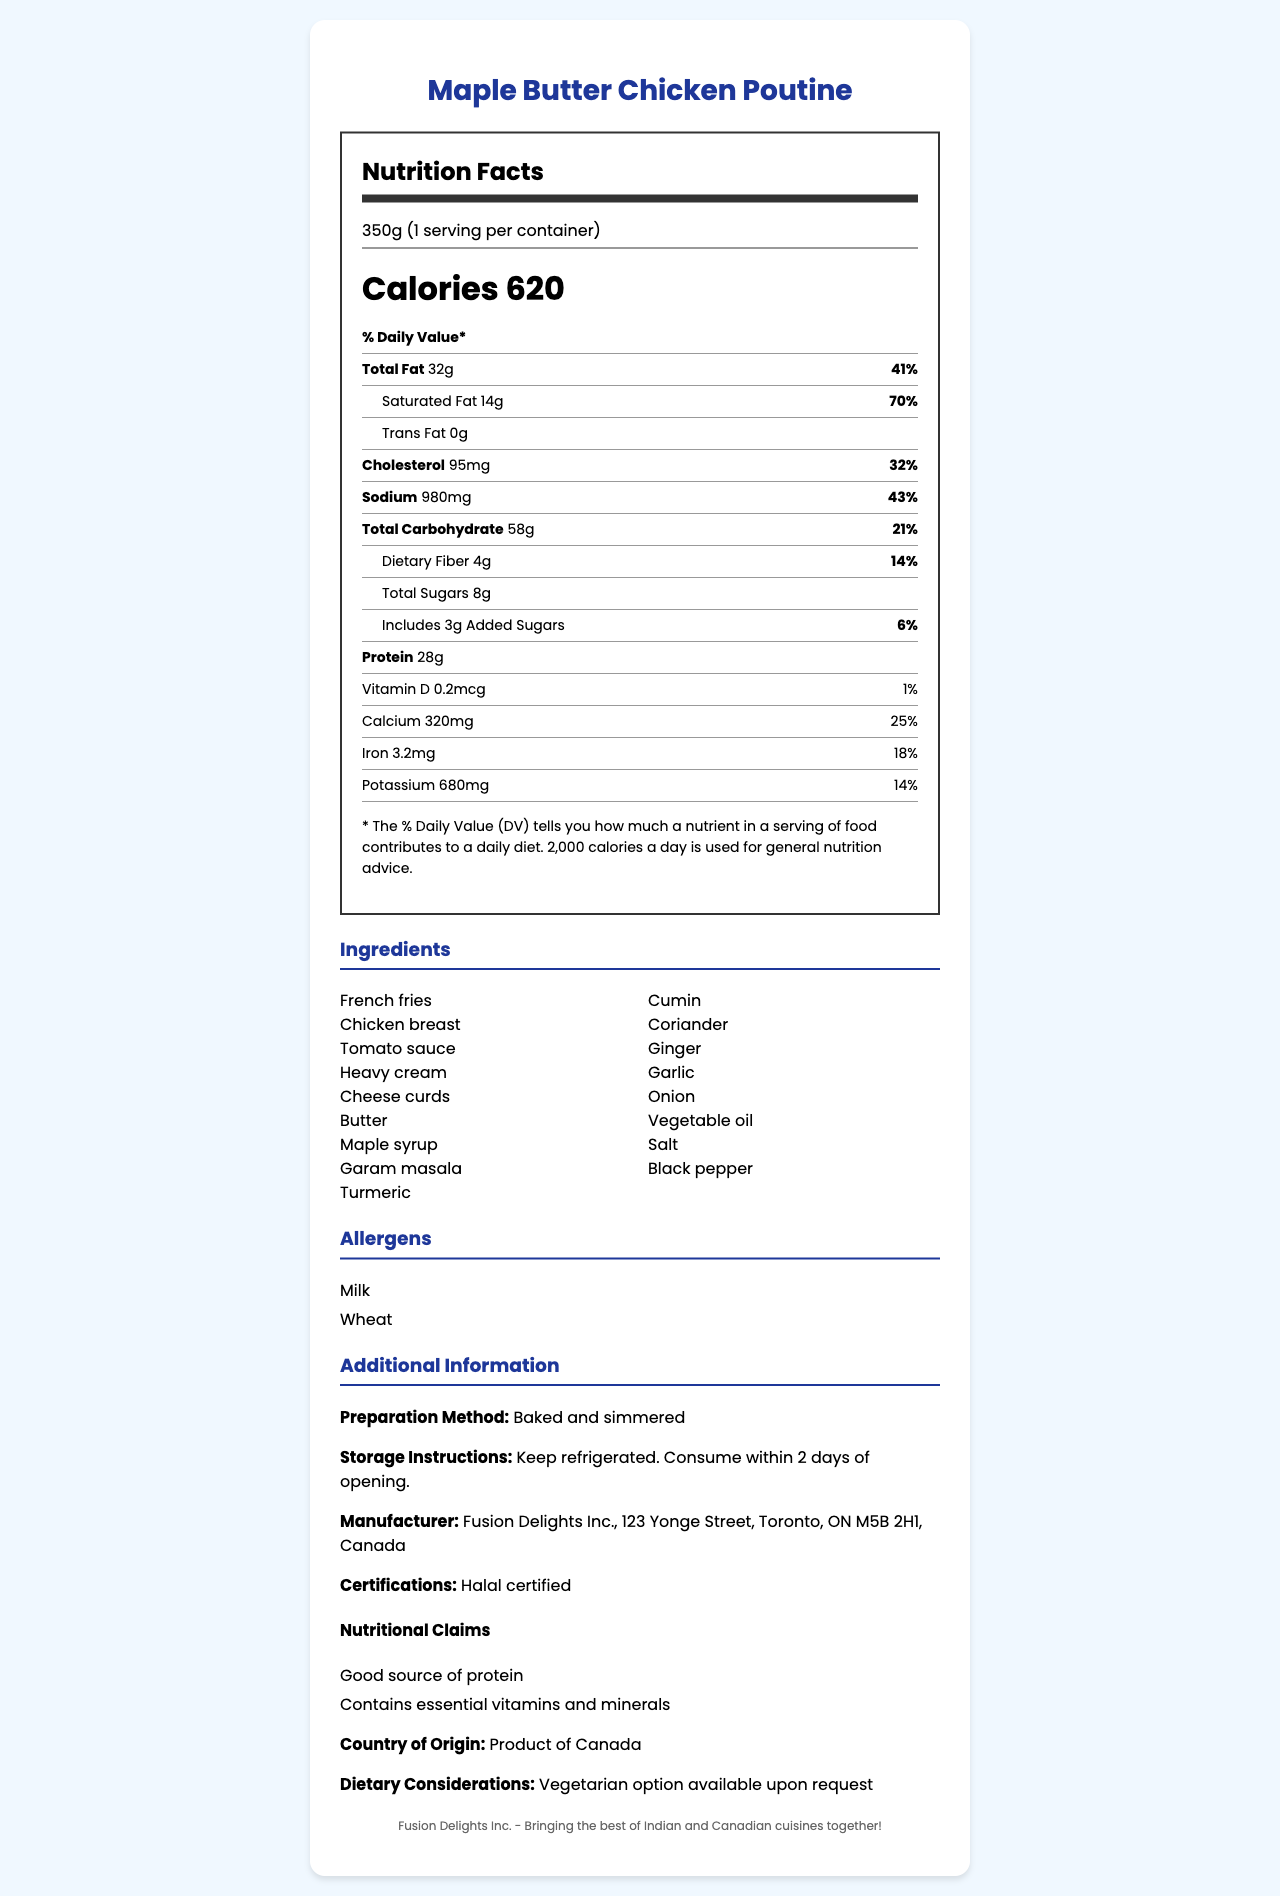what is the serving size for Maple Butter Chicken Poutine? The serving size is clearly listed at the top of the nutrition label as 350g.
Answer: 350g how many calories are there per serving of Maple Butter Chicken Poutine? The nutrition label shows that there are 620 calories per serving.
Answer: 620 what percentage of the Daily Value does the saturated fat constitute? The label specifies that saturated fat is 14g and constitutes 70% of the Daily Value.
Answer: 70% is the product Halal certified? The additional information under certifications mentions that the product is Halal certified.
Answer: Yes how much protein is in a serving of this dish? The nutrition label states that there are 28g of protein per serving.
Answer: 28g how many grams of added sugars are in this dish? A. 8g B. 3g C. 4g D. 2g The nutrition label indicates that there are 3g of added sugars in the dish.
Answer: B what is the manufacturer’s address? The manufacturer's address is detailed in the additional information section.
Answer: 123 Yonge Street, Toronto, ON M5B 2H1, Canada which of the following ingredients is used in the Maple Butter Chicken Poutine? A. Basil B. Coriander C. Oregano D. Paprika From the list of ingredients, coriander is included, whereas basil, oregano, and paprika are not.
Answer: B is there a vegetarian option available for this dish? The additional information mentions that a vegetarian option is available upon request.
Answer: Yes summarize the document The document gives a comprehensive overview of the Maple Butter Chicken Poutine, including its nutritional details, ingredients, allergens, preparation, storage, manufacturer, certifications, and special dietary information.
Answer: The document provides a detailed nutrition facts label for the Maple Butter Chicken Poutine, a multicultural dish combining Indian and Canadian cuisines. It includes information about serving size, number of servings per container, calories, and nutrient content including fats, cholesterol, sodium, carbohydrates, dietary fiber, sugars, and protein. It lists ingredients, allergens, preparation and storage instructions, manufacturer details, certifications, nutritional claims, country of origin, and dietary considerations. The dish is Halal certified and has a vegetarian option available. what are the main allergens present in the Maple Butter Chicken Poutine? The allergens section of the document lists milk and wheat as the primary allergens present in the dish.
Answer: Milk, Wheat what is the daily value percentage for sodium in this dish? The nutrition label states that the sodium content is 980mg, which is 43% of the Daily Value.
Answer: 43% how should the dish be stored after opening? A. Freezer B. Refrigerated C. Room temperature D. In a pantry The storage instructions specify to keep the product refrigerated and consume within 2 days of opening.
Answer: B does this dish provide a good source of vitamin D? The nutrition label shows that the vitamin D content is 0.2mcg, only 1% of the Daily Value, indicating it is not a good source of vitamin D.
Answer: No what is the product name of the dish? The product name is clearly stated at the top of the document.
Answer: Maple Butter Chicken Poutine what are the cooking instructions for this dish? The document does not provide specific cooking instructions, it only mentions that it is baked and simmered.
Answer: Cannot be determined what percentage of the daily value does the protein content cover? The document does not include the Daily Value percentage for protein content.
Answer: Not mentioned what kind of oil might be used in the preparation of this dish? The ingredients list mentions vegetable oil as one of the components.
Answer: Vegetable oil 